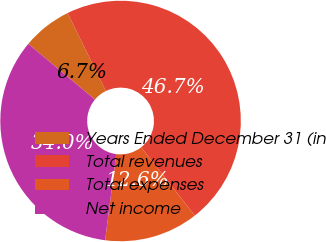Convert chart. <chart><loc_0><loc_0><loc_500><loc_500><pie_chart><fcel>Years Ended December 31 (in<fcel>Total revenues<fcel>Total expenses<fcel>Net income<nl><fcel>6.66%<fcel>46.67%<fcel>12.64%<fcel>34.03%<nl></chart> 